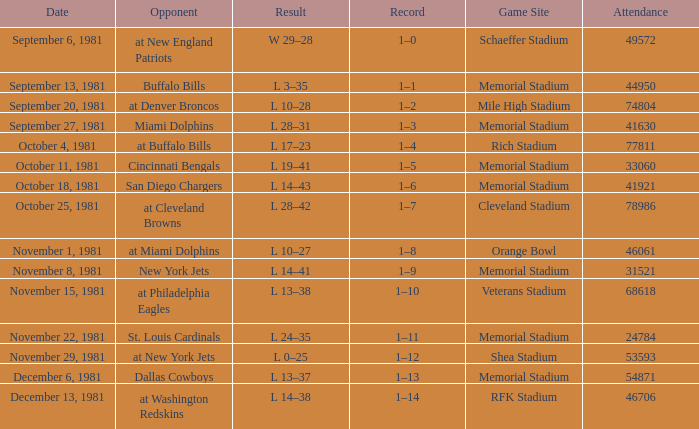During week 2, what is the performance? 1–1. 